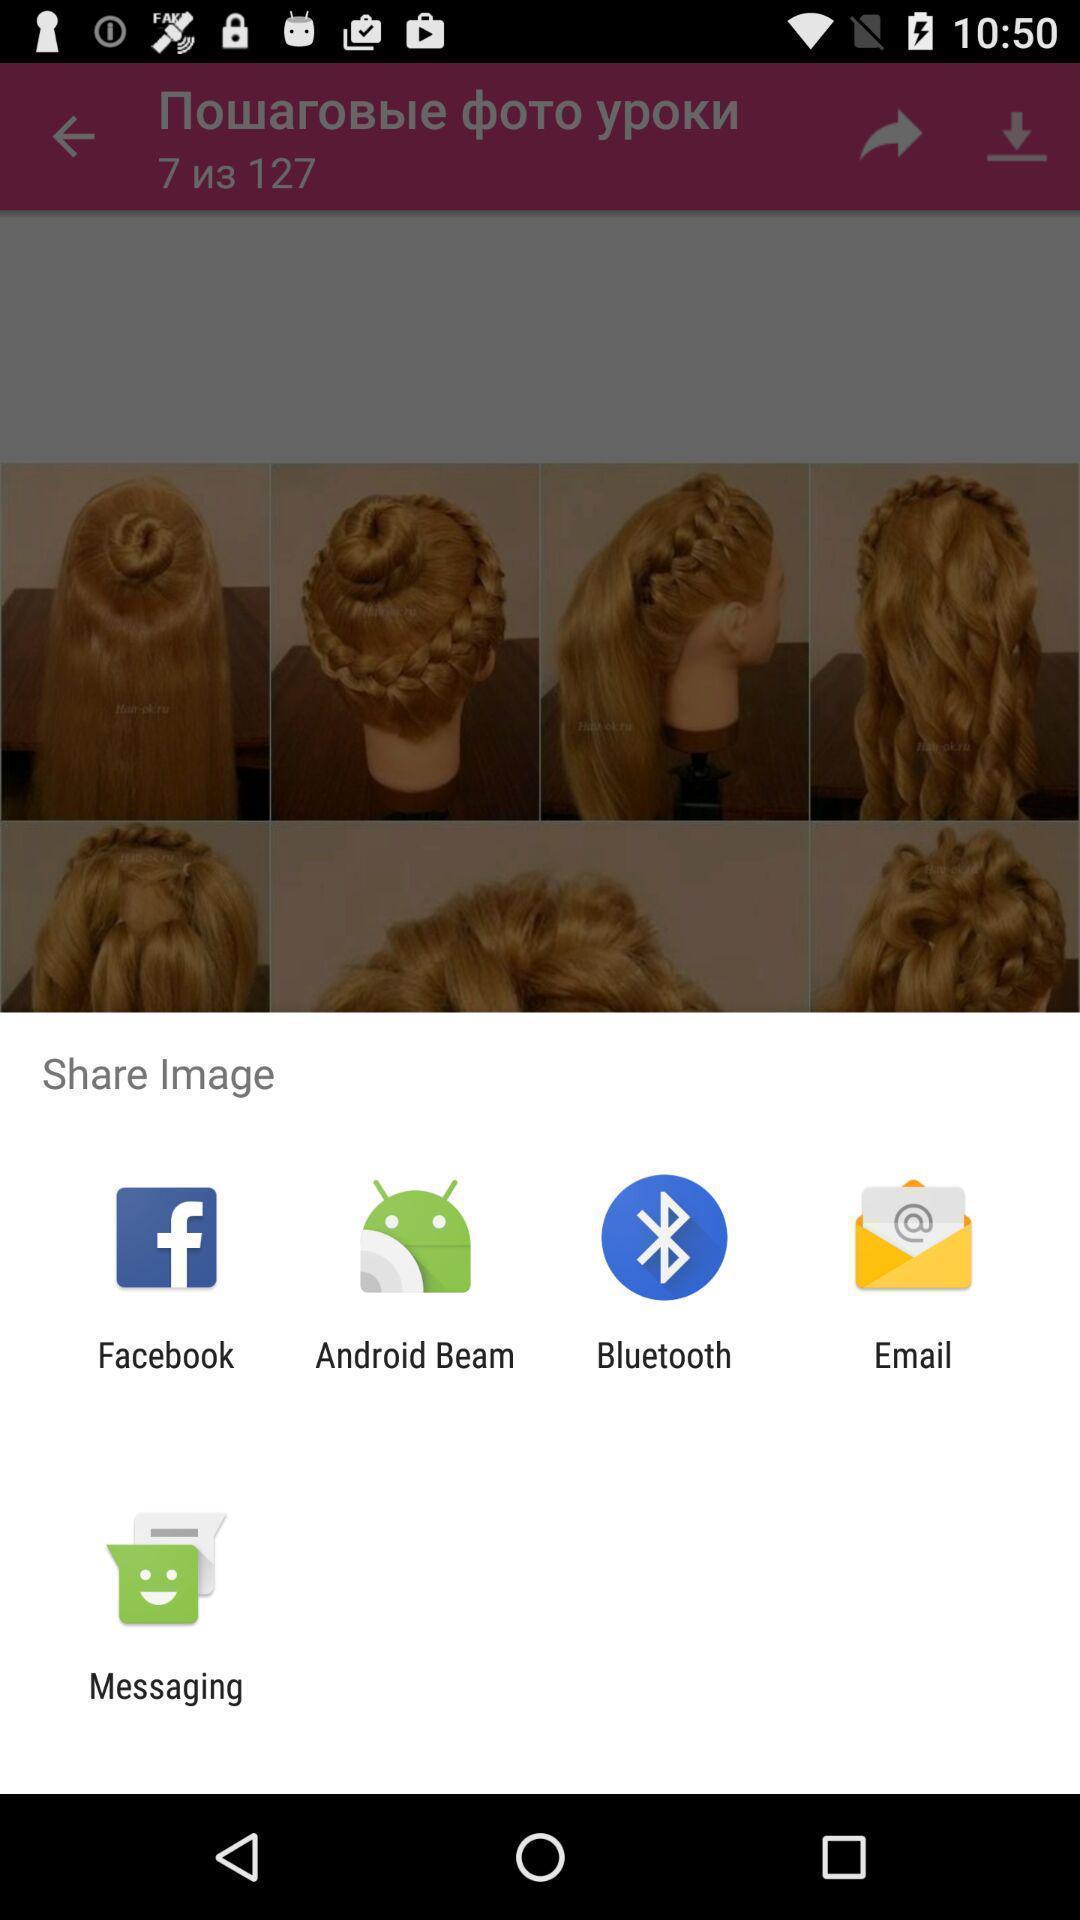Describe the visual elements of this screenshot. Pop-up showing for social app. 